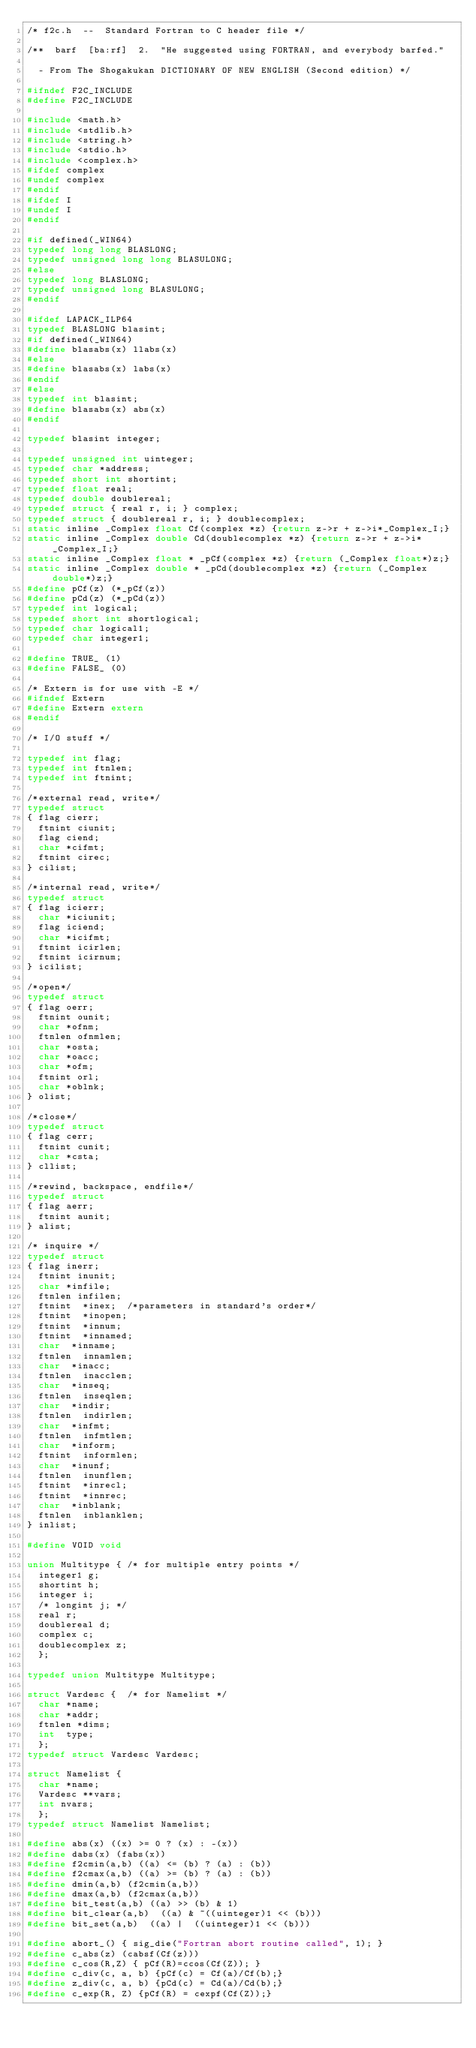<code> <loc_0><loc_0><loc_500><loc_500><_C_>/* f2c.h  --  Standard Fortran to C header file */

/**  barf  [ba:rf]  2.  "He suggested using FORTRAN, and everybody barfed."

	- From The Shogakukan DICTIONARY OF NEW ENGLISH (Second edition) */

#ifndef F2C_INCLUDE
#define F2C_INCLUDE

#include <math.h>
#include <stdlib.h>
#include <string.h>
#include <stdio.h>
#include <complex.h>
#ifdef complex
#undef complex
#endif
#ifdef I
#undef I
#endif

#if defined(_WIN64)
typedef long long BLASLONG;
typedef unsigned long long BLASULONG;
#else
typedef long BLASLONG;
typedef unsigned long BLASULONG;
#endif

#ifdef LAPACK_ILP64
typedef BLASLONG blasint;
#if defined(_WIN64)
#define blasabs(x) llabs(x)
#else
#define blasabs(x) labs(x)
#endif
#else
typedef int blasint;
#define blasabs(x) abs(x)
#endif

typedef blasint integer;

typedef unsigned int uinteger;
typedef char *address;
typedef short int shortint;
typedef float real;
typedef double doublereal;
typedef struct { real r, i; } complex;
typedef struct { doublereal r, i; } doublecomplex;
static inline _Complex float Cf(complex *z) {return z->r + z->i*_Complex_I;}
static inline _Complex double Cd(doublecomplex *z) {return z->r + z->i*_Complex_I;}
static inline _Complex float * _pCf(complex *z) {return (_Complex float*)z;}
static inline _Complex double * _pCd(doublecomplex *z) {return (_Complex double*)z;}
#define pCf(z) (*_pCf(z))
#define pCd(z) (*_pCd(z))
typedef int logical;
typedef short int shortlogical;
typedef char logical1;
typedef char integer1;

#define TRUE_ (1)
#define FALSE_ (0)

/* Extern is for use with -E */
#ifndef Extern
#define Extern extern
#endif

/* I/O stuff */

typedef int flag;
typedef int ftnlen;
typedef int ftnint;

/*external read, write*/
typedef struct
{	flag cierr;
	ftnint ciunit;
	flag ciend;
	char *cifmt;
	ftnint cirec;
} cilist;

/*internal read, write*/
typedef struct
{	flag icierr;
	char *iciunit;
	flag iciend;
	char *icifmt;
	ftnint icirlen;
	ftnint icirnum;
} icilist;

/*open*/
typedef struct
{	flag oerr;
	ftnint ounit;
	char *ofnm;
	ftnlen ofnmlen;
	char *osta;
	char *oacc;
	char *ofm;
	ftnint orl;
	char *oblnk;
} olist;

/*close*/
typedef struct
{	flag cerr;
	ftnint cunit;
	char *csta;
} cllist;

/*rewind, backspace, endfile*/
typedef struct
{	flag aerr;
	ftnint aunit;
} alist;

/* inquire */
typedef struct
{	flag inerr;
	ftnint inunit;
	char *infile;
	ftnlen infilen;
	ftnint	*inex;	/*parameters in standard's order*/
	ftnint	*inopen;
	ftnint	*innum;
	ftnint	*innamed;
	char	*inname;
	ftnlen	innamlen;
	char	*inacc;
	ftnlen	inacclen;
	char	*inseq;
	ftnlen	inseqlen;
	char 	*indir;
	ftnlen	indirlen;
	char	*infmt;
	ftnlen	infmtlen;
	char	*inform;
	ftnint	informlen;
	char	*inunf;
	ftnlen	inunflen;
	ftnint	*inrecl;
	ftnint	*innrec;
	char	*inblank;
	ftnlen	inblanklen;
} inlist;

#define VOID void

union Multitype {	/* for multiple entry points */
	integer1 g;
	shortint h;
	integer i;
	/* longint j; */
	real r;
	doublereal d;
	complex c;
	doublecomplex z;
	};

typedef union Multitype Multitype;

struct Vardesc {	/* for Namelist */
	char *name;
	char *addr;
	ftnlen *dims;
	int  type;
	};
typedef struct Vardesc Vardesc;

struct Namelist {
	char *name;
	Vardesc **vars;
	int nvars;
	};
typedef struct Namelist Namelist;

#define abs(x) ((x) >= 0 ? (x) : -(x))
#define dabs(x) (fabs(x))
#define f2cmin(a,b) ((a) <= (b) ? (a) : (b))
#define f2cmax(a,b) ((a) >= (b) ? (a) : (b))
#define dmin(a,b) (f2cmin(a,b))
#define dmax(a,b) (f2cmax(a,b))
#define bit_test(a,b)	((a) >> (b) & 1)
#define bit_clear(a,b)	((a) & ~((uinteger)1 << (b)))
#define bit_set(a,b)	((a) |  ((uinteger)1 << (b)))

#define abort_() { sig_die("Fortran abort routine called", 1); }
#define c_abs(z) (cabsf(Cf(z)))
#define c_cos(R,Z) { pCf(R)=ccos(Cf(Z)); }
#define c_div(c, a, b) {pCf(c) = Cf(a)/Cf(b);}
#define z_div(c, a, b) {pCd(c) = Cd(a)/Cd(b);}
#define c_exp(R, Z) {pCf(R) = cexpf(Cf(Z));}</code> 